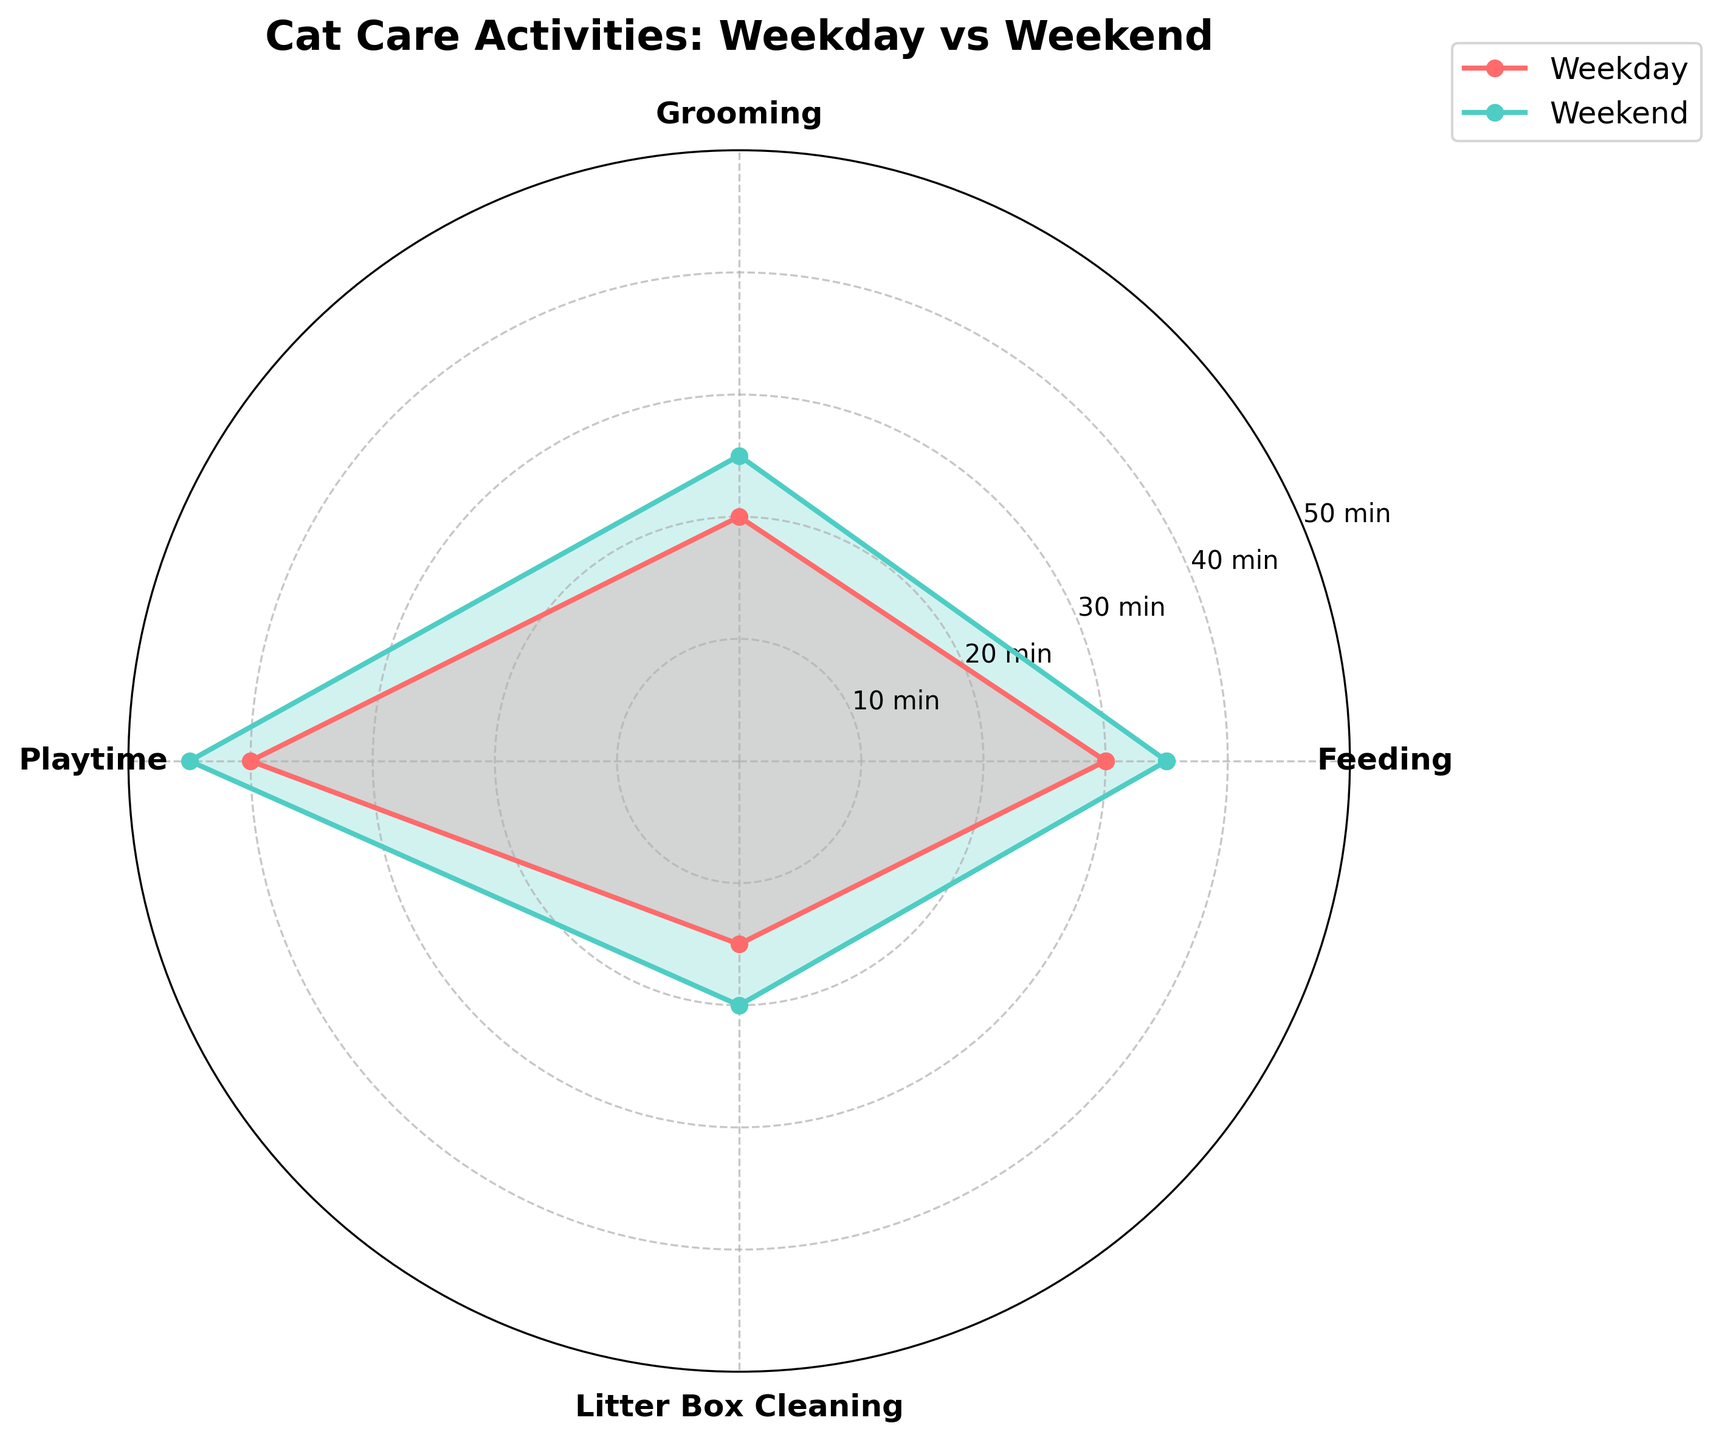What is the title of the chart? The title of the chart is located at the top and specifies the main topic.
Answer: Cat Care Activities: Weekday vs Weekend Which activity takes the most time on both weekdays and weekends? By referring to the highest points on both the weekday and weekend radar plots, we can find that the activity with the highest values is Playtime.
Answer: Playtime How much more time is spent on grooming during weekends compared to weekdays? Compare the values for Grooming on weekends (25 minutes) and weekdays (20 minutes). Subtract the weekday time from the weekend time: 25 - 20.
Answer: 5 minutes Which activities require the least time on weekdays? Look for the smallest value on the weekday radar plot. The smallest time spent on weekdays is for Litter Box Cleaning.
Answer: Litter Box Cleaning Is there any activity where the time spent is the same on both weekdays and weekends? Compare the points for each activity on both the weekday and weekend radial axes. None of the activities have the same time spent on both weekdays and weekends.
Answer: No On which day is more time allocated to each activity on average? Sum the times for all activities on weekdays (30+20+40+15) and weekends (35+25+45+20). Compare the averages by dividing the sums by 4. Weekday Average = 105/4 = 26.25; Weekend Average = 125/4 = 31.25.
Answer: Weekend What are the colors used to represent weekdays and weekends? Identify the colors of the lines and filled areas in the radar chart. Weekdays are represented by a red shade, and weekends by a teal shade.
Answer: Red is Weekday, Teal is Weekend Which activity shows the smallest increase in time from weekdays to weekends? Calculate the difference for each activity between weekends and weekdays: 
- Feeding: 35-30 = 5
- Grooming: 25-20 = 5
- Playtime: 45-40 = 5
- Litter Box Cleaning: 20-15 = 5
All activities show the same increase.
Answer: All activities show equal increase 